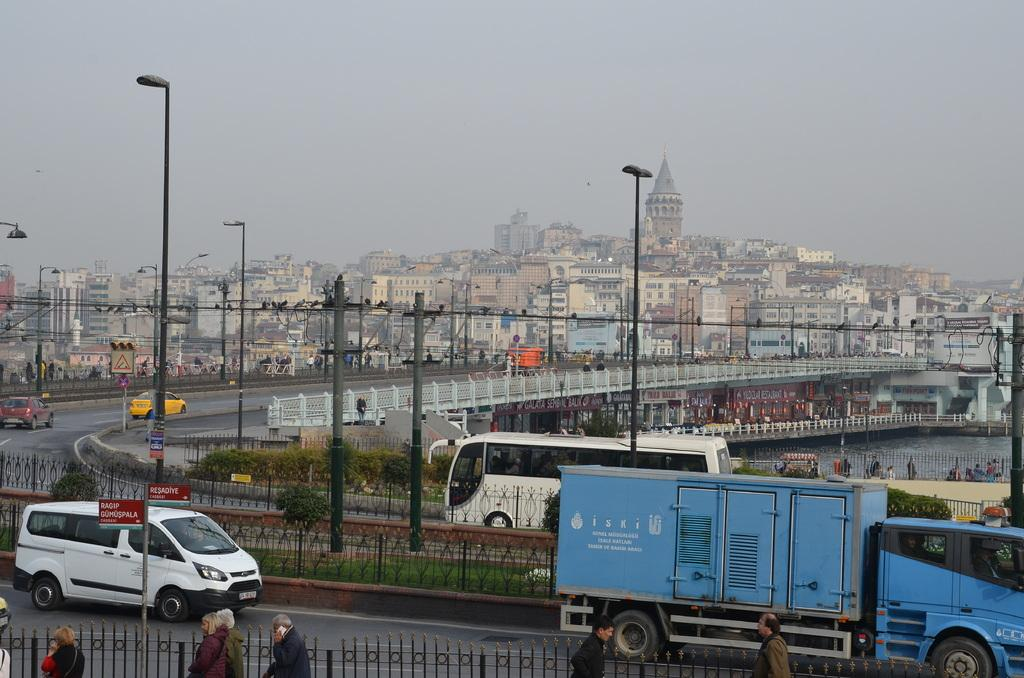What can be seen moving on the road in the image? There are vehicles on the road in the image. What structures are present in the image besides the vehicles? There are poles, people, and birds visible in the image. What can be seen in the background of the image? There is a bridge and buildings in the background of the image. What type of scarf is being used to design the bridge in the image? There is no scarf present in the image, nor is it being used to design the bridge. The bridge is a separate structure in the background. 